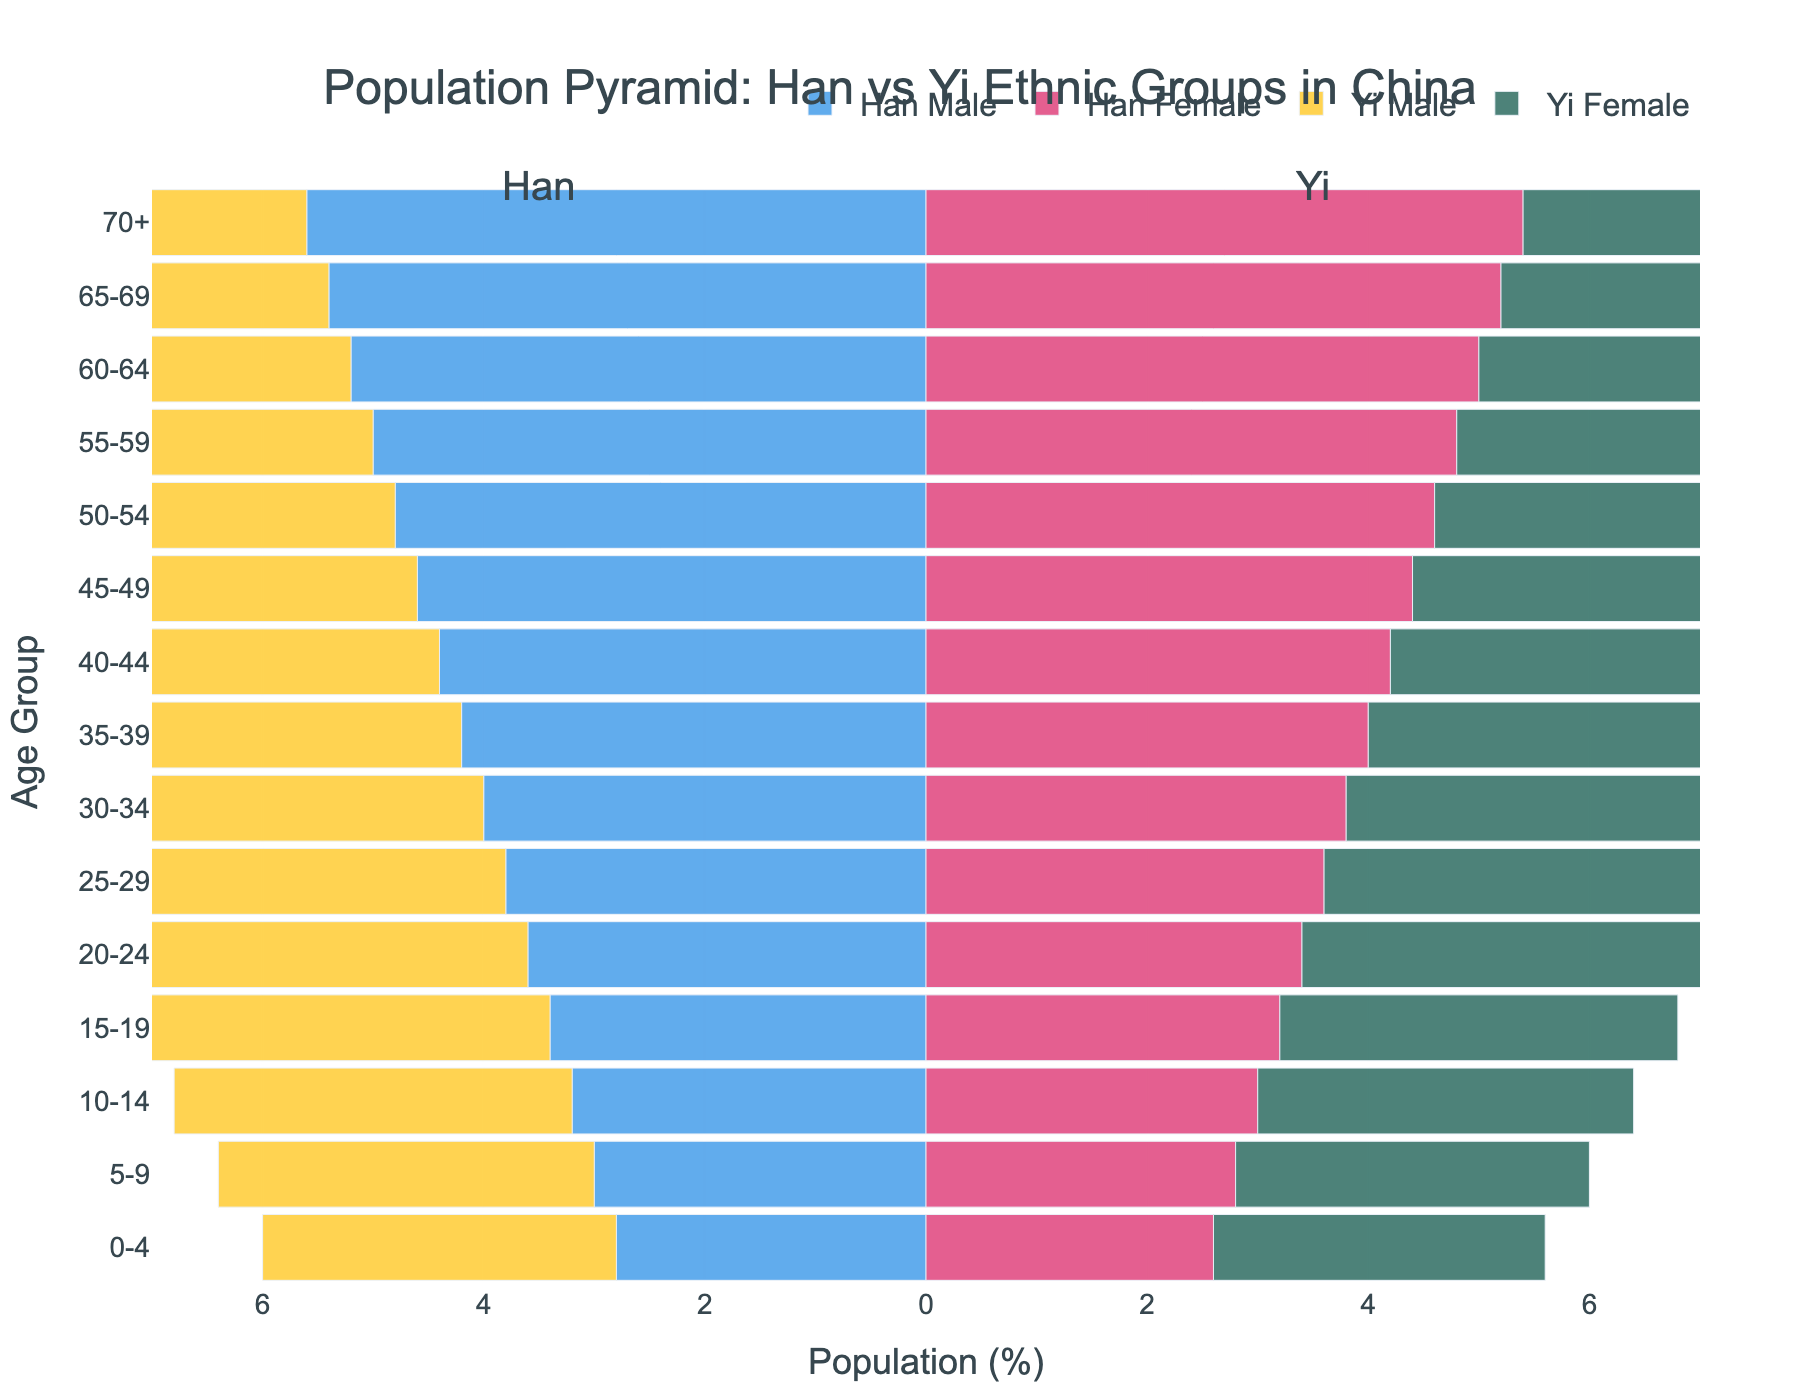What is the title of the figure? The title of the figure is displayed at the top of the chart. It is centered in the layout of the figure.
Answer: Population Pyramid: Han vs Yi Ethnic Groups in China What are the colors representing Han Male and Han Female in the figure? The colors representing Han Male and Han Female can be identified by looking at the legend, which matches the color to the corresponding category.
Answer: Han Male: blue, Han Female: pink Which age group has the highest percentage of Yi Male population? To find the highest percentage for Yi Male, look at the bars for Yi Male on the left side of the pyramid and identify the longest bar.
Answer: 70+ How does the population of Han Female in the age group 20-24 compare to Yi Female in the same age group? Compare the bar lengths for Han Female and Yi Female in the 20-24 age group to see which is longer.
Answer: Yi Female has a higher population What is the total percentage of Yi population (both male and female) in the age group 0-4? Add the percentages of Yi Male and Yi Female in the age group 0-4. Yi Male is 3.2% and Yi Female is 3.0%, summing up to 6.2%.
Answer: 6.2% In the age group 60-64, which group has the higher female population, Han or Yi? Compare the lengths of the Han Female and Yi Female bars in the age group 60-64.
Answer: Yi Is the percentage of Han Male population in the age group 55-59 greater or smaller than the percentage of Yi Male population in the age group 55-59? Look at the bars for Han Male and Yi Male in the age group 55-59 and compare their lengths. Han Male has a bar of -5.0, and Yi Male has a bar of -5.4.
Answer: Smaller What is the average percentage of the Yi Female population across all age groups? Sum the percentages of Yi Female from all age groups and then divide by the number of age groups (15). Sum: 3.0+3.2+3.4+3.6+3.8+4.0+4.2+4.4+4.6+4.8+5.0+5.2+5.4+5.6+5.8 = 64.2. Dividing by 15, the average is 64.2/15 = 4.28%.
Answer: 4.28% Which group has a more balanced male-to-female ratio in older age groups (65-69, 70+), Han or Yi? A balanced male-to-female ratio means the male and female bars are of similar lengths. Compare the lengths of the bars for Han Male and Female versus Yi Male and Female in age groups 65-69 and 70+.
Answer: Yi 